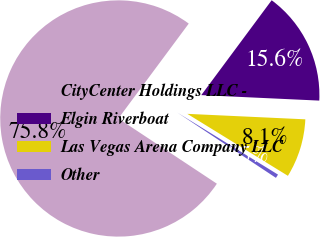Convert chart to OTSL. <chart><loc_0><loc_0><loc_500><loc_500><pie_chart><fcel>CityCenter Holdings LLC -<fcel>Elgin Riverboat<fcel>Las Vegas Arena Company LLC<fcel>Other<nl><fcel>75.85%<fcel>15.58%<fcel>8.05%<fcel>0.52%<nl></chart> 